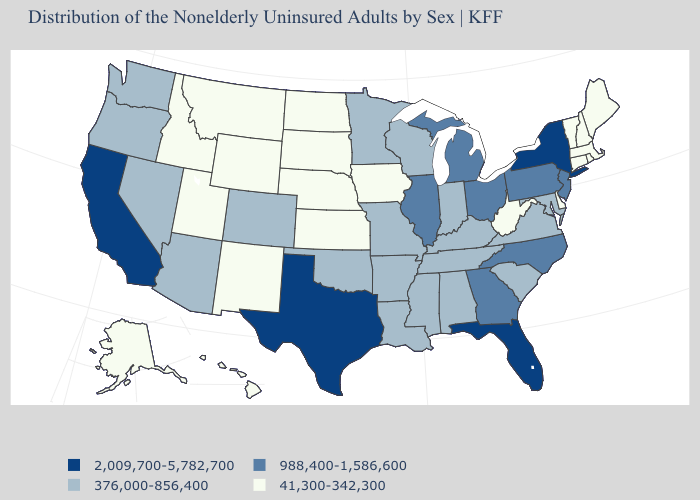Does New Hampshire have the same value as Louisiana?
Give a very brief answer. No. What is the lowest value in states that border Delaware?
Concise answer only. 376,000-856,400. What is the value of Missouri?
Short answer required. 376,000-856,400. What is the value of Oregon?
Short answer required. 376,000-856,400. Does Kentucky have a higher value than Maine?
Give a very brief answer. Yes. Does Texas have the highest value in the South?
Write a very short answer. Yes. What is the highest value in states that border Louisiana?
Short answer required. 2,009,700-5,782,700. What is the value of New York?
Answer briefly. 2,009,700-5,782,700. What is the value of Virginia?
Write a very short answer. 376,000-856,400. Does the map have missing data?
Concise answer only. No. What is the lowest value in states that border New York?
Be succinct. 41,300-342,300. What is the lowest value in the MidWest?
Give a very brief answer. 41,300-342,300. Does Washington have the highest value in the USA?
Keep it brief. No. What is the lowest value in the South?
Write a very short answer. 41,300-342,300. Name the states that have a value in the range 2,009,700-5,782,700?
Answer briefly. California, Florida, New York, Texas. 